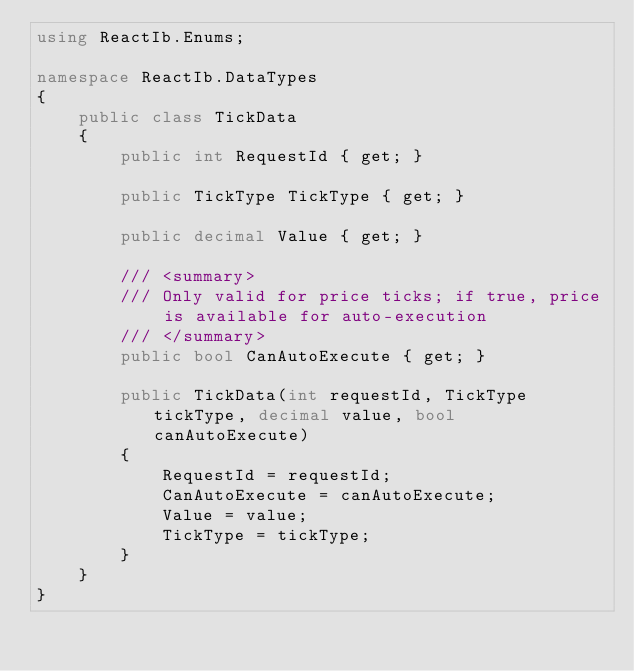Convert code to text. <code><loc_0><loc_0><loc_500><loc_500><_C#_>using ReactIb.Enums;

namespace ReactIb.DataTypes
{
    public class TickData
    {
        public int RequestId { get; }

        public TickType TickType { get; }

        public decimal Value { get; }

        /// <summary>
        /// Only valid for price ticks; if true, price is available for auto-execution
        /// </summary>
        public bool CanAutoExecute { get; }

        public TickData(int requestId, TickType tickType, decimal value, bool canAutoExecute)
        {
            RequestId = requestId;
            CanAutoExecute = canAutoExecute;
            Value = value;
            TickType = tickType;
        }
    }
}</code> 